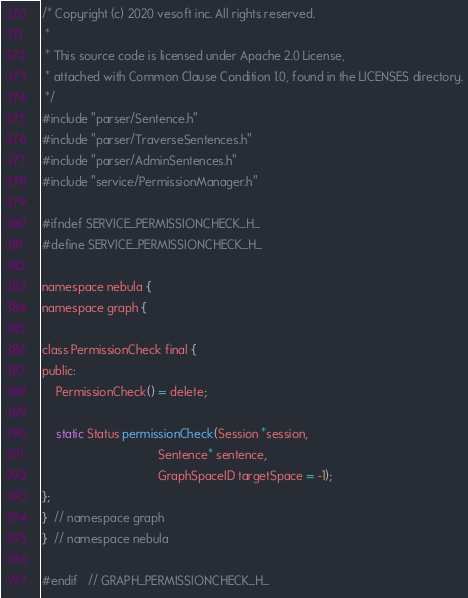<code> <loc_0><loc_0><loc_500><loc_500><_C_>/* Copyright (c) 2020 vesoft inc. All rights reserved.
 *
 * This source code is licensed under Apache 2.0 License,
 * attached with Common Clause Condition 1.0, found in the LICENSES directory.
 */
#include "parser/Sentence.h"
#include "parser/TraverseSentences.h"
#include "parser/AdminSentences.h"
#include "service/PermissionManager.h"

#ifndef SERVICE_PERMISSIONCHECK_H_
#define SERVICE_PERMISSIONCHECK_H_

namespace nebula {
namespace graph {

class PermissionCheck final {
public:
    PermissionCheck() = delete;

    static Status permissionCheck(Session *session,
                                  Sentence* sentence,
                                  GraphSpaceID targetSpace = -1);
};
}  // namespace graph
}  // namespace nebula

#endif   // GRAPH_PERMISSIONCHECK_H_
</code> 